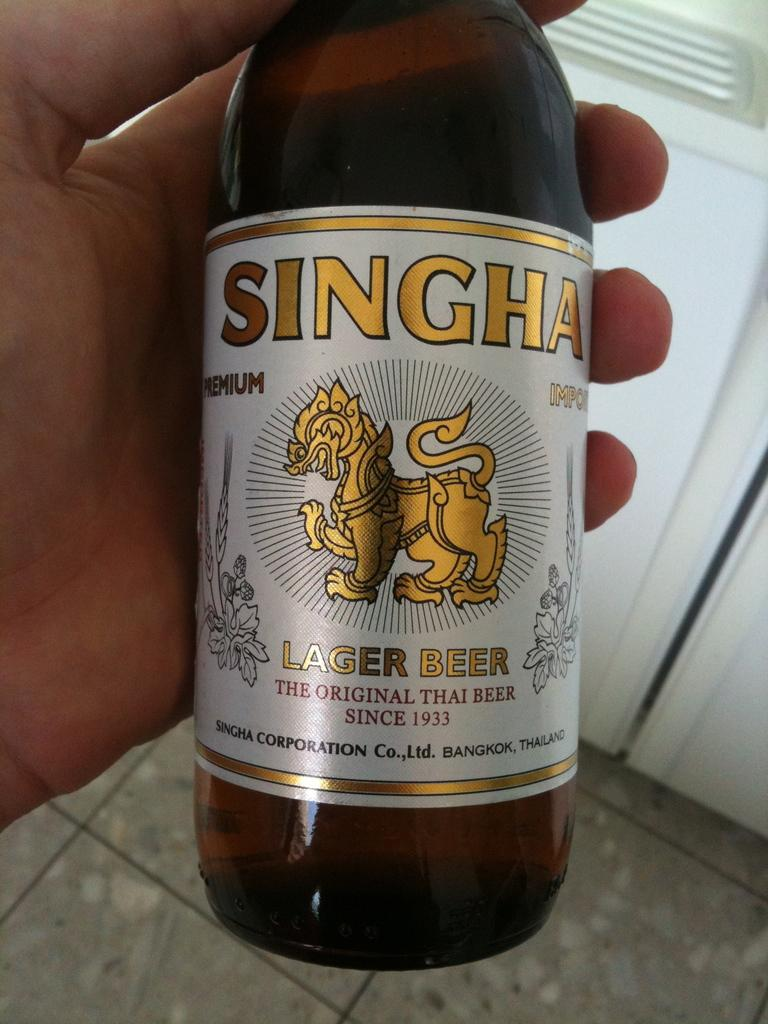<image>
Provide a brief description of the given image. Someone holding Singha Lager Beer in their hand. 